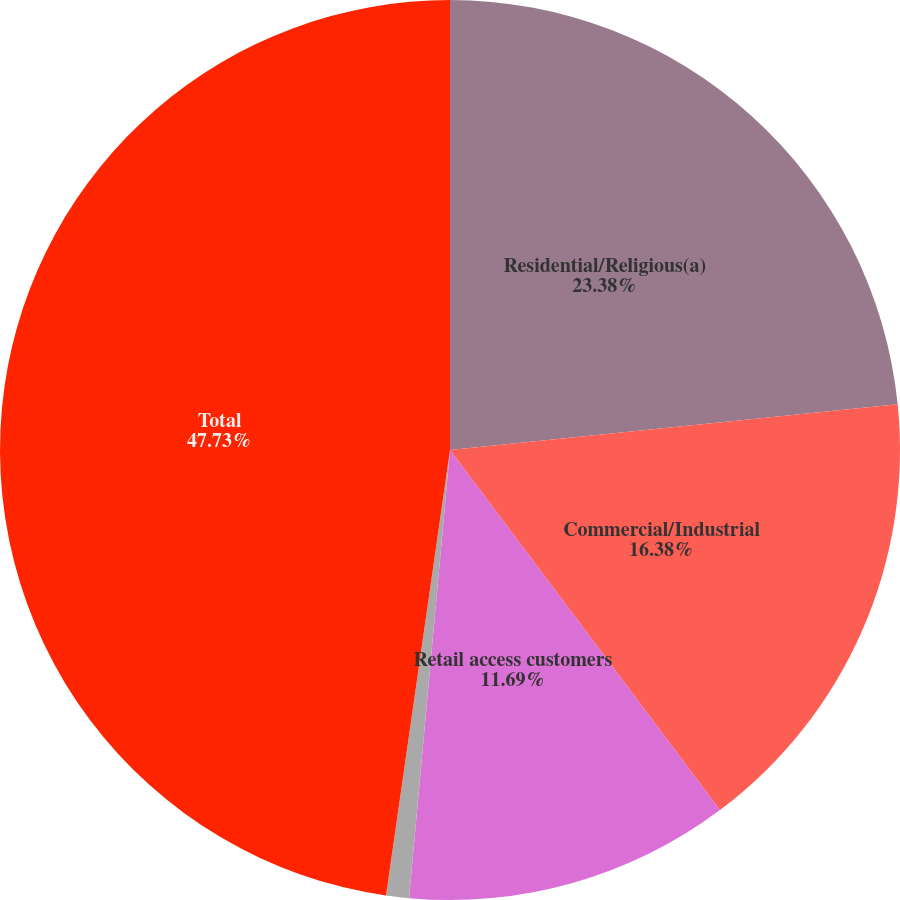<chart> <loc_0><loc_0><loc_500><loc_500><pie_chart><fcel>Residential/Religious(a)<fcel>Commercial/Industrial<fcel>Retail access customers<fcel>Public authorities<fcel>Total<nl><fcel>23.38%<fcel>16.38%<fcel>11.69%<fcel>0.82%<fcel>47.73%<nl></chart> 